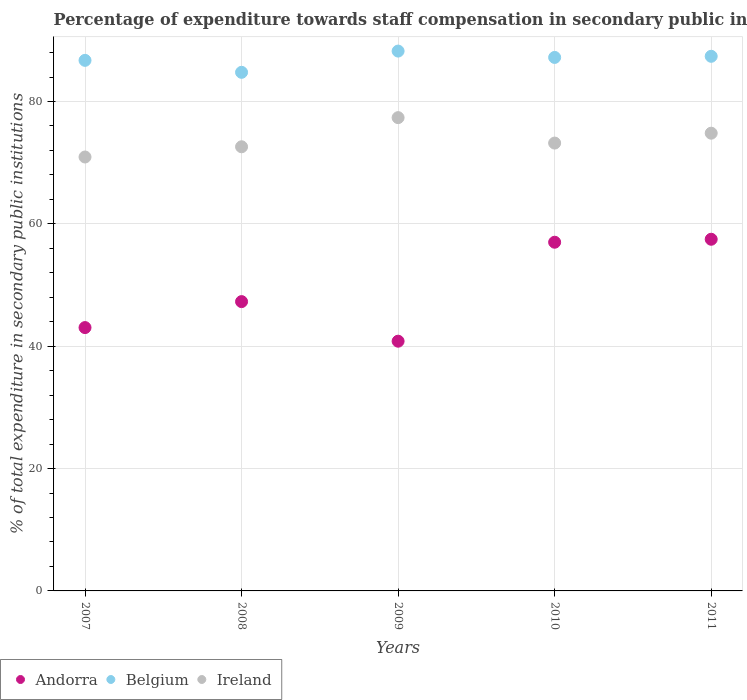How many different coloured dotlines are there?
Your response must be concise. 3. Is the number of dotlines equal to the number of legend labels?
Provide a succinct answer. Yes. What is the percentage of expenditure towards staff compensation in Belgium in 2010?
Offer a terse response. 87.2. Across all years, what is the maximum percentage of expenditure towards staff compensation in Andorra?
Provide a succinct answer. 57.48. Across all years, what is the minimum percentage of expenditure towards staff compensation in Belgium?
Ensure brevity in your answer.  84.77. What is the total percentage of expenditure towards staff compensation in Ireland in the graph?
Your response must be concise. 368.9. What is the difference between the percentage of expenditure towards staff compensation in Belgium in 2008 and that in 2009?
Your response must be concise. -3.47. What is the difference between the percentage of expenditure towards staff compensation in Belgium in 2011 and the percentage of expenditure towards staff compensation in Andorra in 2008?
Ensure brevity in your answer.  40.1. What is the average percentage of expenditure towards staff compensation in Andorra per year?
Make the answer very short. 49.12. In the year 2010, what is the difference between the percentage of expenditure towards staff compensation in Ireland and percentage of expenditure towards staff compensation in Andorra?
Ensure brevity in your answer.  16.21. What is the ratio of the percentage of expenditure towards staff compensation in Belgium in 2008 to that in 2011?
Give a very brief answer. 0.97. Is the difference between the percentage of expenditure towards staff compensation in Ireland in 2009 and 2010 greater than the difference between the percentage of expenditure towards staff compensation in Andorra in 2009 and 2010?
Provide a succinct answer. Yes. What is the difference between the highest and the second highest percentage of expenditure towards staff compensation in Ireland?
Your answer should be compact. 2.54. What is the difference between the highest and the lowest percentage of expenditure towards staff compensation in Ireland?
Your answer should be very brief. 6.43. Is it the case that in every year, the sum of the percentage of expenditure towards staff compensation in Ireland and percentage of expenditure towards staff compensation in Andorra  is greater than the percentage of expenditure towards staff compensation in Belgium?
Ensure brevity in your answer.  Yes. How many dotlines are there?
Your response must be concise. 3. How many years are there in the graph?
Make the answer very short. 5. What is the difference between two consecutive major ticks on the Y-axis?
Your answer should be very brief. 20. Does the graph contain any zero values?
Provide a succinct answer. No. Does the graph contain grids?
Offer a terse response. Yes. How many legend labels are there?
Provide a short and direct response. 3. What is the title of the graph?
Ensure brevity in your answer.  Percentage of expenditure towards staff compensation in secondary public institutions. What is the label or title of the Y-axis?
Keep it short and to the point. % of total expenditure in secondary public institutions. What is the % of total expenditure in secondary public institutions in Andorra in 2007?
Give a very brief answer. 43.04. What is the % of total expenditure in secondary public institutions of Belgium in 2007?
Ensure brevity in your answer.  86.72. What is the % of total expenditure in secondary public institutions in Ireland in 2007?
Give a very brief answer. 70.93. What is the % of total expenditure in secondary public institutions of Andorra in 2008?
Provide a succinct answer. 47.29. What is the % of total expenditure in secondary public institutions of Belgium in 2008?
Your answer should be compact. 84.77. What is the % of total expenditure in secondary public institutions in Ireland in 2008?
Your response must be concise. 72.6. What is the % of total expenditure in secondary public institutions in Andorra in 2009?
Offer a terse response. 40.82. What is the % of total expenditure in secondary public institutions of Belgium in 2009?
Offer a very short reply. 88.24. What is the % of total expenditure in secondary public institutions of Ireland in 2009?
Your answer should be compact. 77.36. What is the % of total expenditure in secondary public institutions in Andorra in 2010?
Offer a terse response. 56.99. What is the % of total expenditure in secondary public institutions in Belgium in 2010?
Provide a succinct answer. 87.2. What is the % of total expenditure in secondary public institutions of Ireland in 2010?
Ensure brevity in your answer.  73.2. What is the % of total expenditure in secondary public institutions in Andorra in 2011?
Make the answer very short. 57.48. What is the % of total expenditure in secondary public institutions of Belgium in 2011?
Offer a very short reply. 87.38. What is the % of total expenditure in secondary public institutions in Ireland in 2011?
Keep it short and to the point. 74.82. Across all years, what is the maximum % of total expenditure in secondary public institutions of Andorra?
Your answer should be very brief. 57.48. Across all years, what is the maximum % of total expenditure in secondary public institutions of Belgium?
Keep it short and to the point. 88.24. Across all years, what is the maximum % of total expenditure in secondary public institutions of Ireland?
Your answer should be very brief. 77.36. Across all years, what is the minimum % of total expenditure in secondary public institutions of Andorra?
Offer a terse response. 40.82. Across all years, what is the minimum % of total expenditure in secondary public institutions of Belgium?
Give a very brief answer. 84.77. Across all years, what is the minimum % of total expenditure in secondary public institutions of Ireland?
Keep it short and to the point. 70.93. What is the total % of total expenditure in secondary public institutions of Andorra in the graph?
Your response must be concise. 245.62. What is the total % of total expenditure in secondary public institutions of Belgium in the graph?
Your response must be concise. 434.31. What is the total % of total expenditure in secondary public institutions in Ireland in the graph?
Make the answer very short. 368.9. What is the difference between the % of total expenditure in secondary public institutions in Andorra in 2007 and that in 2008?
Provide a succinct answer. -4.25. What is the difference between the % of total expenditure in secondary public institutions of Belgium in 2007 and that in 2008?
Your answer should be very brief. 1.96. What is the difference between the % of total expenditure in secondary public institutions of Ireland in 2007 and that in 2008?
Offer a terse response. -1.67. What is the difference between the % of total expenditure in secondary public institutions of Andorra in 2007 and that in 2009?
Give a very brief answer. 2.22. What is the difference between the % of total expenditure in secondary public institutions of Belgium in 2007 and that in 2009?
Keep it short and to the point. -1.52. What is the difference between the % of total expenditure in secondary public institutions of Ireland in 2007 and that in 2009?
Provide a succinct answer. -6.43. What is the difference between the % of total expenditure in secondary public institutions in Andorra in 2007 and that in 2010?
Provide a succinct answer. -13.95. What is the difference between the % of total expenditure in secondary public institutions of Belgium in 2007 and that in 2010?
Make the answer very short. -0.48. What is the difference between the % of total expenditure in secondary public institutions in Ireland in 2007 and that in 2010?
Your answer should be compact. -2.28. What is the difference between the % of total expenditure in secondary public institutions in Andorra in 2007 and that in 2011?
Provide a succinct answer. -14.44. What is the difference between the % of total expenditure in secondary public institutions of Belgium in 2007 and that in 2011?
Make the answer very short. -0.66. What is the difference between the % of total expenditure in secondary public institutions in Ireland in 2007 and that in 2011?
Your answer should be compact. -3.89. What is the difference between the % of total expenditure in secondary public institutions in Andorra in 2008 and that in 2009?
Your response must be concise. 6.47. What is the difference between the % of total expenditure in secondary public institutions in Belgium in 2008 and that in 2009?
Your answer should be compact. -3.47. What is the difference between the % of total expenditure in secondary public institutions in Ireland in 2008 and that in 2009?
Give a very brief answer. -4.76. What is the difference between the % of total expenditure in secondary public institutions of Andorra in 2008 and that in 2010?
Keep it short and to the point. -9.71. What is the difference between the % of total expenditure in secondary public institutions in Belgium in 2008 and that in 2010?
Keep it short and to the point. -2.43. What is the difference between the % of total expenditure in secondary public institutions in Ireland in 2008 and that in 2010?
Offer a very short reply. -0.6. What is the difference between the % of total expenditure in secondary public institutions of Andorra in 2008 and that in 2011?
Your response must be concise. -10.19. What is the difference between the % of total expenditure in secondary public institutions in Belgium in 2008 and that in 2011?
Your answer should be compact. -2.62. What is the difference between the % of total expenditure in secondary public institutions of Ireland in 2008 and that in 2011?
Ensure brevity in your answer.  -2.22. What is the difference between the % of total expenditure in secondary public institutions of Andorra in 2009 and that in 2010?
Ensure brevity in your answer.  -16.18. What is the difference between the % of total expenditure in secondary public institutions in Belgium in 2009 and that in 2010?
Offer a terse response. 1.04. What is the difference between the % of total expenditure in secondary public institutions of Ireland in 2009 and that in 2010?
Offer a very short reply. 4.16. What is the difference between the % of total expenditure in secondary public institutions of Andorra in 2009 and that in 2011?
Keep it short and to the point. -16.66. What is the difference between the % of total expenditure in secondary public institutions of Belgium in 2009 and that in 2011?
Your answer should be compact. 0.85. What is the difference between the % of total expenditure in secondary public institutions in Ireland in 2009 and that in 2011?
Offer a terse response. 2.54. What is the difference between the % of total expenditure in secondary public institutions in Andorra in 2010 and that in 2011?
Your response must be concise. -0.49. What is the difference between the % of total expenditure in secondary public institutions of Belgium in 2010 and that in 2011?
Your answer should be very brief. -0.18. What is the difference between the % of total expenditure in secondary public institutions in Ireland in 2010 and that in 2011?
Your answer should be compact. -1.62. What is the difference between the % of total expenditure in secondary public institutions in Andorra in 2007 and the % of total expenditure in secondary public institutions in Belgium in 2008?
Provide a succinct answer. -41.72. What is the difference between the % of total expenditure in secondary public institutions of Andorra in 2007 and the % of total expenditure in secondary public institutions of Ireland in 2008?
Offer a very short reply. -29.55. What is the difference between the % of total expenditure in secondary public institutions of Belgium in 2007 and the % of total expenditure in secondary public institutions of Ireland in 2008?
Keep it short and to the point. 14.12. What is the difference between the % of total expenditure in secondary public institutions of Andorra in 2007 and the % of total expenditure in secondary public institutions of Belgium in 2009?
Provide a succinct answer. -45.2. What is the difference between the % of total expenditure in secondary public institutions in Andorra in 2007 and the % of total expenditure in secondary public institutions in Ireland in 2009?
Give a very brief answer. -34.32. What is the difference between the % of total expenditure in secondary public institutions in Belgium in 2007 and the % of total expenditure in secondary public institutions in Ireland in 2009?
Provide a succinct answer. 9.36. What is the difference between the % of total expenditure in secondary public institutions in Andorra in 2007 and the % of total expenditure in secondary public institutions in Belgium in 2010?
Provide a short and direct response. -44.16. What is the difference between the % of total expenditure in secondary public institutions of Andorra in 2007 and the % of total expenditure in secondary public institutions of Ireland in 2010?
Offer a terse response. -30.16. What is the difference between the % of total expenditure in secondary public institutions of Belgium in 2007 and the % of total expenditure in secondary public institutions of Ireland in 2010?
Your response must be concise. 13.52. What is the difference between the % of total expenditure in secondary public institutions in Andorra in 2007 and the % of total expenditure in secondary public institutions in Belgium in 2011?
Your response must be concise. -44.34. What is the difference between the % of total expenditure in secondary public institutions in Andorra in 2007 and the % of total expenditure in secondary public institutions in Ireland in 2011?
Your answer should be very brief. -31.77. What is the difference between the % of total expenditure in secondary public institutions of Belgium in 2007 and the % of total expenditure in secondary public institutions of Ireland in 2011?
Ensure brevity in your answer.  11.9. What is the difference between the % of total expenditure in secondary public institutions of Andorra in 2008 and the % of total expenditure in secondary public institutions of Belgium in 2009?
Provide a short and direct response. -40.95. What is the difference between the % of total expenditure in secondary public institutions of Andorra in 2008 and the % of total expenditure in secondary public institutions of Ireland in 2009?
Your answer should be very brief. -30.07. What is the difference between the % of total expenditure in secondary public institutions in Belgium in 2008 and the % of total expenditure in secondary public institutions in Ireland in 2009?
Offer a very short reply. 7.41. What is the difference between the % of total expenditure in secondary public institutions in Andorra in 2008 and the % of total expenditure in secondary public institutions in Belgium in 2010?
Keep it short and to the point. -39.91. What is the difference between the % of total expenditure in secondary public institutions of Andorra in 2008 and the % of total expenditure in secondary public institutions of Ireland in 2010?
Offer a very short reply. -25.91. What is the difference between the % of total expenditure in secondary public institutions of Belgium in 2008 and the % of total expenditure in secondary public institutions of Ireland in 2010?
Your answer should be compact. 11.56. What is the difference between the % of total expenditure in secondary public institutions in Andorra in 2008 and the % of total expenditure in secondary public institutions in Belgium in 2011?
Make the answer very short. -40.1. What is the difference between the % of total expenditure in secondary public institutions of Andorra in 2008 and the % of total expenditure in secondary public institutions of Ireland in 2011?
Ensure brevity in your answer.  -27.53. What is the difference between the % of total expenditure in secondary public institutions of Belgium in 2008 and the % of total expenditure in secondary public institutions of Ireland in 2011?
Keep it short and to the point. 9.95. What is the difference between the % of total expenditure in secondary public institutions of Andorra in 2009 and the % of total expenditure in secondary public institutions of Belgium in 2010?
Ensure brevity in your answer.  -46.38. What is the difference between the % of total expenditure in secondary public institutions in Andorra in 2009 and the % of total expenditure in secondary public institutions in Ireland in 2010?
Your response must be concise. -32.38. What is the difference between the % of total expenditure in secondary public institutions of Belgium in 2009 and the % of total expenditure in secondary public institutions of Ireland in 2010?
Keep it short and to the point. 15.04. What is the difference between the % of total expenditure in secondary public institutions of Andorra in 2009 and the % of total expenditure in secondary public institutions of Belgium in 2011?
Give a very brief answer. -46.57. What is the difference between the % of total expenditure in secondary public institutions of Andorra in 2009 and the % of total expenditure in secondary public institutions of Ireland in 2011?
Offer a very short reply. -34. What is the difference between the % of total expenditure in secondary public institutions in Belgium in 2009 and the % of total expenditure in secondary public institutions in Ireland in 2011?
Your response must be concise. 13.42. What is the difference between the % of total expenditure in secondary public institutions in Andorra in 2010 and the % of total expenditure in secondary public institutions in Belgium in 2011?
Offer a very short reply. -30.39. What is the difference between the % of total expenditure in secondary public institutions in Andorra in 2010 and the % of total expenditure in secondary public institutions in Ireland in 2011?
Give a very brief answer. -17.82. What is the difference between the % of total expenditure in secondary public institutions of Belgium in 2010 and the % of total expenditure in secondary public institutions of Ireland in 2011?
Your answer should be very brief. 12.38. What is the average % of total expenditure in secondary public institutions in Andorra per year?
Offer a terse response. 49.12. What is the average % of total expenditure in secondary public institutions in Belgium per year?
Keep it short and to the point. 86.86. What is the average % of total expenditure in secondary public institutions of Ireland per year?
Ensure brevity in your answer.  73.78. In the year 2007, what is the difference between the % of total expenditure in secondary public institutions of Andorra and % of total expenditure in secondary public institutions of Belgium?
Ensure brevity in your answer.  -43.68. In the year 2007, what is the difference between the % of total expenditure in secondary public institutions of Andorra and % of total expenditure in secondary public institutions of Ireland?
Give a very brief answer. -27.88. In the year 2007, what is the difference between the % of total expenditure in secondary public institutions of Belgium and % of total expenditure in secondary public institutions of Ireland?
Your answer should be very brief. 15.8. In the year 2008, what is the difference between the % of total expenditure in secondary public institutions in Andorra and % of total expenditure in secondary public institutions in Belgium?
Give a very brief answer. -37.48. In the year 2008, what is the difference between the % of total expenditure in secondary public institutions of Andorra and % of total expenditure in secondary public institutions of Ireland?
Provide a succinct answer. -25.31. In the year 2008, what is the difference between the % of total expenditure in secondary public institutions in Belgium and % of total expenditure in secondary public institutions in Ireland?
Make the answer very short. 12.17. In the year 2009, what is the difference between the % of total expenditure in secondary public institutions of Andorra and % of total expenditure in secondary public institutions of Belgium?
Your answer should be very brief. -47.42. In the year 2009, what is the difference between the % of total expenditure in secondary public institutions in Andorra and % of total expenditure in secondary public institutions in Ireland?
Give a very brief answer. -36.54. In the year 2009, what is the difference between the % of total expenditure in secondary public institutions in Belgium and % of total expenditure in secondary public institutions in Ireland?
Your answer should be very brief. 10.88. In the year 2010, what is the difference between the % of total expenditure in secondary public institutions in Andorra and % of total expenditure in secondary public institutions in Belgium?
Offer a very short reply. -30.21. In the year 2010, what is the difference between the % of total expenditure in secondary public institutions of Andorra and % of total expenditure in secondary public institutions of Ireland?
Offer a terse response. -16.21. In the year 2010, what is the difference between the % of total expenditure in secondary public institutions of Belgium and % of total expenditure in secondary public institutions of Ireland?
Keep it short and to the point. 14. In the year 2011, what is the difference between the % of total expenditure in secondary public institutions in Andorra and % of total expenditure in secondary public institutions in Belgium?
Offer a terse response. -29.9. In the year 2011, what is the difference between the % of total expenditure in secondary public institutions in Andorra and % of total expenditure in secondary public institutions in Ireland?
Offer a very short reply. -17.34. In the year 2011, what is the difference between the % of total expenditure in secondary public institutions in Belgium and % of total expenditure in secondary public institutions in Ireland?
Your answer should be compact. 12.57. What is the ratio of the % of total expenditure in secondary public institutions in Andorra in 2007 to that in 2008?
Your answer should be compact. 0.91. What is the ratio of the % of total expenditure in secondary public institutions of Belgium in 2007 to that in 2008?
Ensure brevity in your answer.  1.02. What is the ratio of the % of total expenditure in secondary public institutions of Andorra in 2007 to that in 2009?
Make the answer very short. 1.05. What is the ratio of the % of total expenditure in secondary public institutions of Belgium in 2007 to that in 2009?
Your response must be concise. 0.98. What is the ratio of the % of total expenditure in secondary public institutions in Ireland in 2007 to that in 2009?
Your answer should be compact. 0.92. What is the ratio of the % of total expenditure in secondary public institutions in Andorra in 2007 to that in 2010?
Offer a very short reply. 0.76. What is the ratio of the % of total expenditure in secondary public institutions in Belgium in 2007 to that in 2010?
Offer a very short reply. 0.99. What is the ratio of the % of total expenditure in secondary public institutions in Ireland in 2007 to that in 2010?
Keep it short and to the point. 0.97. What is the ratio of the % of total expenditure in secondary public institutions of Andorra in 2007 to that in 2011?
Offer a very short reply. 0.75. What is the ratio of the % of total expenditure in secondary public institutions of Ireland in 2007 to that in 2011?
Make the answer very short. 0.95. What is the ratio of the % of total expenditure in secondary public institutions of Andorra in 2008 to that in 2009?
Your answer should be compact. 1.16. What is the ratio of the % of total expenditure in secondary public institutions in Belgium in 2008 to that in 2009?
Your response must be concise. 0.96. What is the ratio of the % of total expenditure in secondary public institutions in Ireland in 2008 to that in 2009?
Keep it short and to the point. 0.94. What is the ratio of the % of total expenditure in secondary public institutions of Andorra in 2008 to that in 2010?
Your response must be concise. 0.83. What is the ratio of the % of total expenditure in secondary public institutions in Belgium in 2008 to that in 2010?
Offer a very short reply. 0.97. What is the ratio of the % of total expenditure in secondary public institutions in Andorra in 2008 to that in 2011?
Ensure brevity in your answer.  0.82. What is the ratio of the % of total expenditure in secondary public institutions in Ireland in 2008 to that in 2011?
Offer a terse response. 0.97. What is the ratio of the % of total expenditure in secondary public institutions of Andorra in 2009 to that in 2010?
Make the answer very short. 0.72. What is the ratio of the % of total expenditure in secondary public institutions of Belgium in 2009 to that in 2010?
Ensure brevity in your answer.  1.01. What is the ratio of the % of total expenditure in secondary public institutions in Ireland in 2009 to that in 2010?
Offer a very short reply. 1.06. What is the ratio of the % of total expenditure in secondary public institutions of Andorra in 2009 to that in 2011?
Provide a succinct answer. 0.71. What is the ratio of the % of total expenditure in secondary public institutions of Belgium in 2009 to that in 2011?
Ensure brevity in your answer.  1.01. What is the ratio of the % of total expenditure in secondary public institutions in Ireland in 2009 to that in 2011?
Your answer should be compact. 1.03. What is the ratio of the % of total expenditure in secondary public institutions of Andorra in 2010 to that in 2011?
Provide a succinct answer. 0.99. What is the ratio of the % of total expenditure in secondary public institutions in Ireland in 2010 to that in 2011?
Offer a very short reply. 0.98. What is the difference between the highest and the second highest % of total expenditure in secondary public institutions in Andorra?
Provide a succinct answer. 0.49. What is the difference between the highest and the second highest % of total expenditure in secondary public institutions in Belgium?
Provide a succinct answer. 0.85. What is the difference between the highest and the second highest % of total expenditure in secondary public institutions in Ireland?
Your answer should be very brief. 2.54. What is the difference between the highest and the lowest % of total expenditure in secondary public institutions of Andorra?
Offer a terse response. 16.66. What is the difference between the highest and the lowest % of total expenditure in secondary public institutions in Belgium?
Your answer should be compact. 3.47. What is the difference between the highest and the lowest % of total expenditure in secondary public institutions of Ireland?
Your answer should be compact. 6.43. 